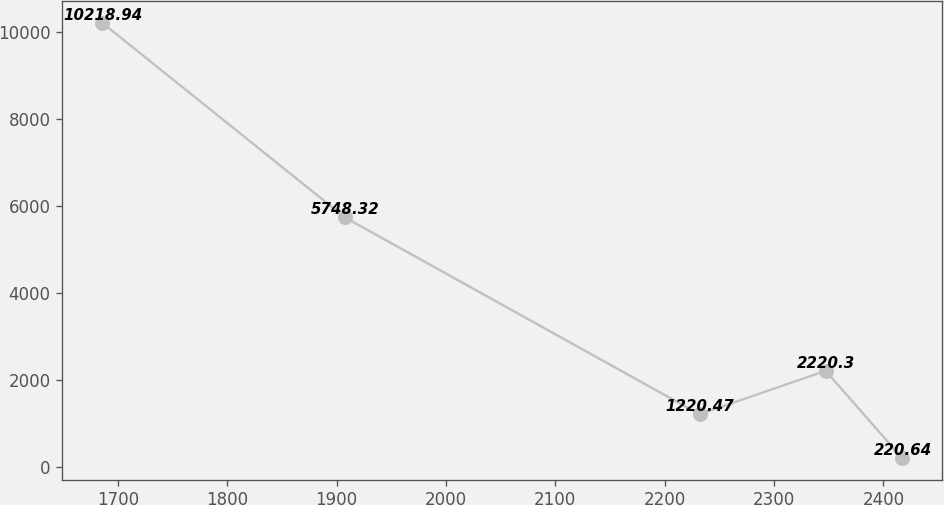Convert chart to OTSL. <chart><loc_0><loc_0><loc_500><loc_500><line_chart><ecel><fcel>Unnamed: 1<nl><fcel>1685.75<fcel>10218.9<nl><fcel>1907.49<fcel>5748.32<nl><fcel>2231.83<fcel>1220.47<nl><fcel>2347.2<fcel>2220.3<nl><fcel>2416.97<fcel>220.64<nl></chart> 